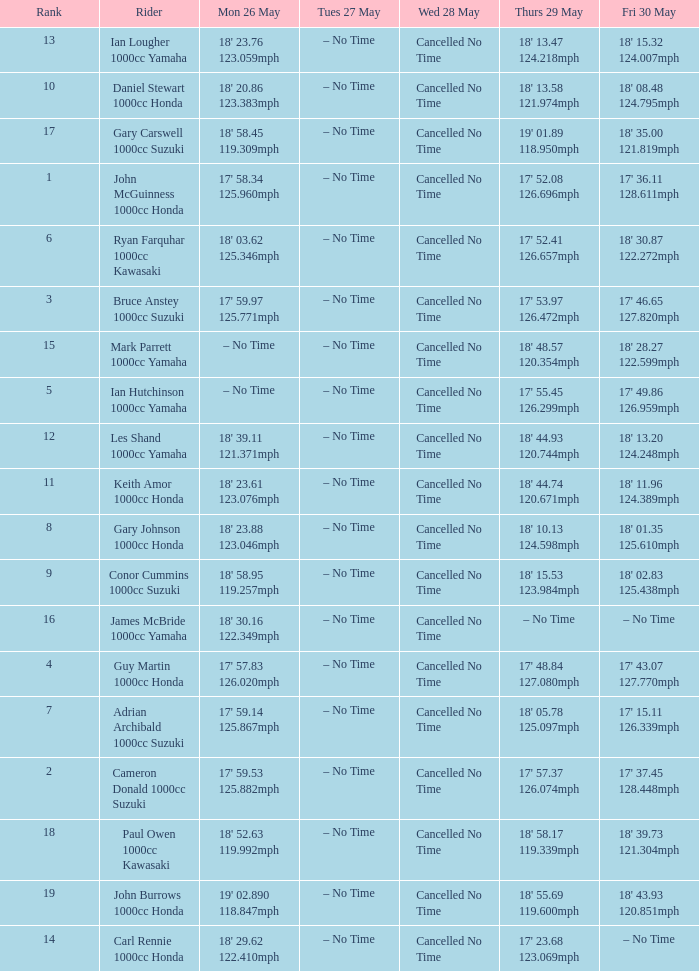What time is mon may 26 and fri may 30 is 18' 28.27 122.599mph? – No Time. 